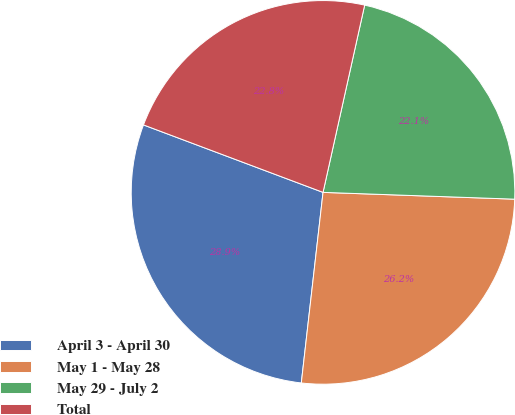Convert chart. <chart><loc_0><loc_0><loc_500><loc_500><pie_chart><fcel>April 3 - April 30<fcel>May 1 - May 28<fcel>May 29 - July 2<fcel>Total<nl><fcel>28.91%<fcel>26.24%<fcel>22.08%<fcel>22.76%<nl></chart> 